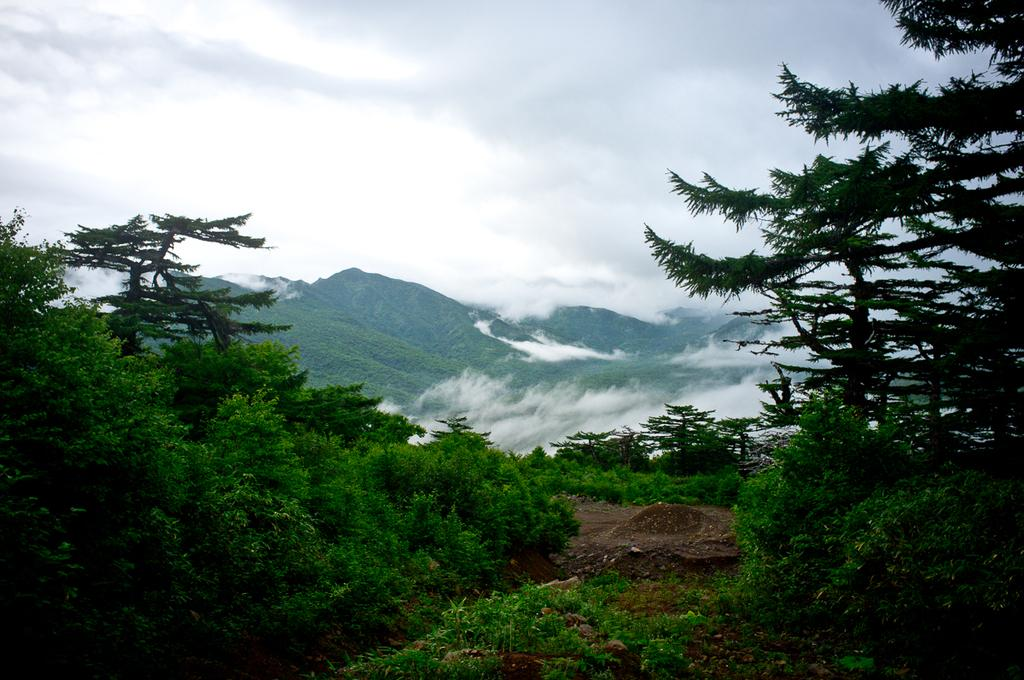What type of vegetation can be seen in the image? There are trees in the image. What else can be seen on the ground in the image? There is grass in the image. What is visible at the top of the image? The sky is visible at the top of the image. What type of guitar can be seen in the image? There is no guitar present in the image. What color is the ink used to draw the oranges in the image? There are no oranges or ink present in the image; it features trees and grass. 